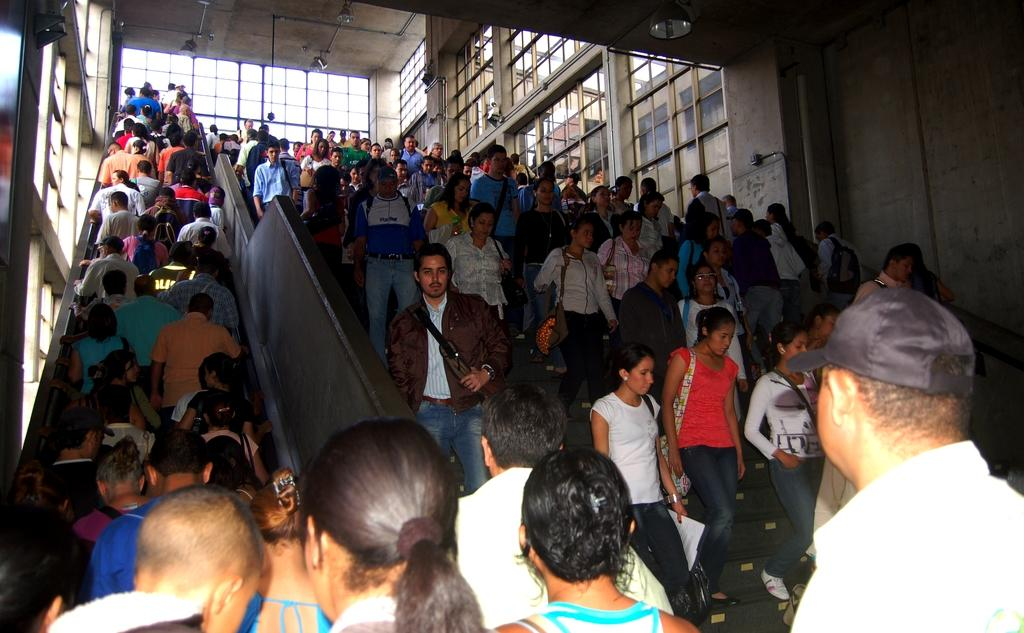What are the people in the image doing? The people in the image are on the stairs. What can be seen on the left side of the image? There are windows on the left side of the image. What can be seen on the right side of the image? There are windows on the right side of the image. What is visible at the top of the image? There are lights visible at the top of the image. What type of pancake is being served on the stairs in the image? There is no pancake present in the image; it features people on the stairs and windows on both sides. How do the people in the image feel about the stairs? The image does not convey any emotions or feelings of the people, so it cannot be determined how they feel about the stairs. 